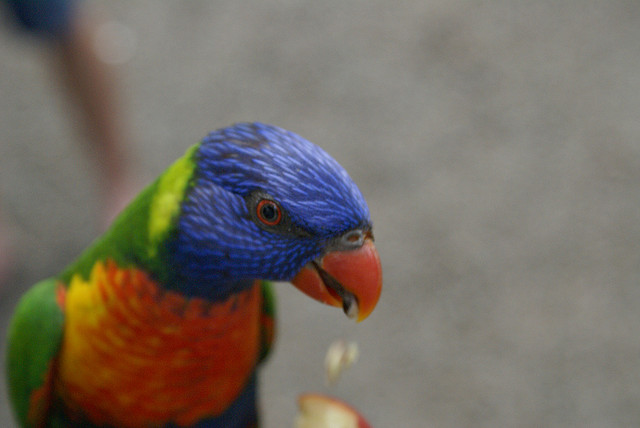<image>Who is holding the cup? There is no one holding the cup in the image. Who is holding the cup? It is unanswerable who is holding the cup. There is no cup in the image. 